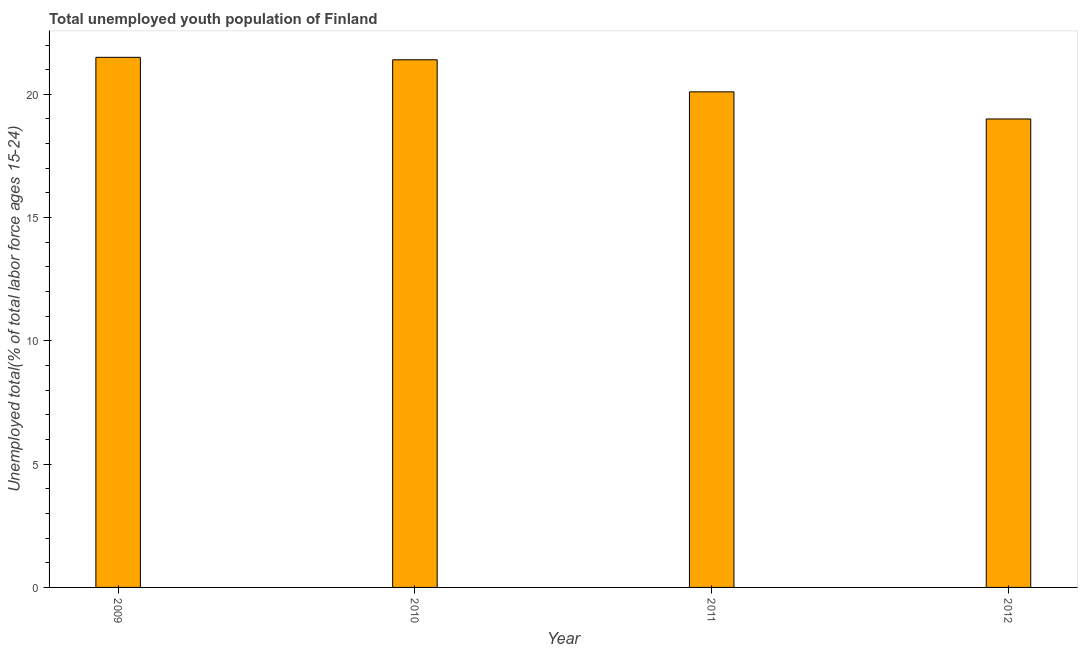Does the graph contain grids?
Keep it short and to the point. No. What is the title of the graph?
Offer a very short reply. Total unemployed youth population of Finland. What is the label or title of the Y-axis?
Make the answer very short. Unemployed total(% of total labor force ages 15-24). What is the unemployed youth in 2012?
Make the answer very short. 19. In which year was the unemployed youth minimum?
Make the answer very short. 2012. What is the sum of the unemployed youth?
Provide a succinct answer. 82. What is the median unemployed youth?
Give a very brief answer. 20.75. What is the ratio of the unemployed youth in 2009 to that in 2012?
Offer a terse response. 1.13. Is the difference between the unemployed youth in 2009 and 2011 greater than the difference between any two years?
Provide a succinct answer. No. What is the difference between the highest and the second highest unemployed youth?
Provide a succinct answer. 0.1. Is the sum of the unemployed youth in 2009 and 2012 greater than the maximum unemployed youth across all years?
Keep it short and to the point. Yes. In how many years, is the unemployed youth greater than the average unemployed youth taken over all years?
Give a very brief answer. 2. What is the difference between two consecutive major ticks on the Y-axis?
Offer a very short reply. 5. Are the values on the major ticks of Y-axis written in scientific E-notation?
Provide a short and direct response. No. What is the Unemployed total(% of total labor force ages 15-24) in 2010?
Offer a terse response. 21.4. What is the Unemployed total(% of total labor force ages 15-24) in 2011?
Your response must be concise. 20.1. What is the Unemployed total(% of total labor force ages 15-24) of 2012?
Give a very brief answer. 19. What is the difference between the Unemployed total(% of total labor force ages 15-24) in 2009 and 2011?
Keep it short and to the point. 1.4. What is the difference between the Unemployed total(% of total labor force ages 15-24) in 2010 and 2011?
Your answer should be very brief. 1.3. What is the difference between the Unemployed total(% of total labor force ages 15-24) in 2010 and 2012?
Make the answer very short. 2.4. What is the difference between the Unemployed total(% of total labor force ages 15-24) in 2011 and 2012?
Make the answer very short. 1.1. What is the ratio of the Unemployed total(% of total labor force ages 15-24) in 2009 to that in 2011?
Make the answer very short. 1.07. What is the ratio of the Unemployed total(% of total labor force ages 15-24) in 2009 to that in 2012?
Your response must be concise. 1.13. What is the ratio of the Unemployed total(% of total labor force ages 15-24) in 2010 to that in 2011?
Make the answer very short. 1.06. What is the ratio of the Unemployed total(% of total labor force ages 15-24) in 2010 to that in 2012?
Provide a succinct answer. 1.13. What is the ratio of the Unemployed total(% of total labor force ages 15-24) in 2011 to that in 2012?
Keep it short and to the point. 1.06. 